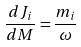Convert formula to latex. <formula><loc_0><loc_0><loc_500><loc_500>\frac { d J _ { i } } { d M } = \frac { m _ { i } } { \omega }</formula> 